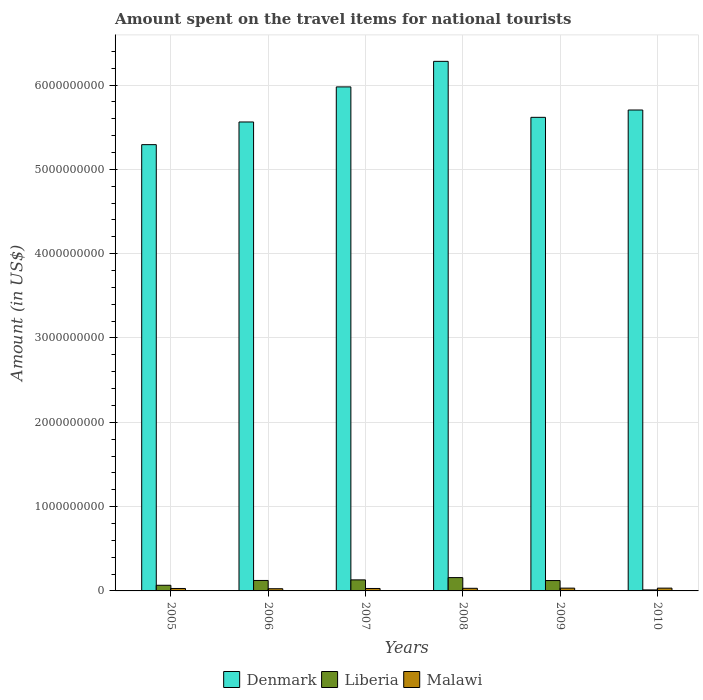How many different coloured bars are there?
Keep it short and to the point. 3. How many groups of bars are there?
Ensure brevity in your answer.  6. Are the number of bars per tick equal to the number of legend labels?
Your response must be concise. Yes. Are the number of bars on each tick of the X-axis equal?
Make the answer very short. Yes. How many bars are there on the 1st tick from the left?
Keep it short and to the point. 3. What is the label of the 3rd group of bars from the left?
Provide a short and direct response. 2007. What is the amount spent on the travel items for national tourists in Denmark in 2008?
Offer a terse response. 6.28e+09. Across all years, what is the maximum amount spent on the travel items for national tourists in Denmark?
Make the answer very short. 6.28e+09. Across all years, what is the minimum amount spent on the travel items for national tourists in Denmark?
Keep it short and to the point. 5.29e+09. In which year was the amount spent on the travel items for national tourists in Malawi minimum?
Offer a terse response. 2006. What is the total amount spent on the travel items for national tourists in Liberia in the graph?
Provide a short and direct response. 6.15e+08. What is the difference between the amount spent on the travel items for national tourists in Malawi in 2005 and that in 2009?
Provide a succinct answer. -4.00e+06. What is the difference between the amount spent on the travel items for national tourists in Malawi in 2010 and the amount spent on the travel items for national tourists in Denmark in 2009?
Keep it short and to the point. -5.58e+09. What is the average amount spent on the travel items for national tourists in Liberia per year?
Your answer should be compact. 1.02e+08. In the year 2007, what is the difference between the amount spent on the travel items for national tourists in Malawi and amount spent on the travel items for national tourists in Denmark?
Your answer should be very brief. -5.95e+09. What is the ratio of the amount spent on the travel items for national tourists in Malawi in 2006 to that in 2009?
Offer a very short reply. 0.79. Is the difference between the amount spent on the travel items for national tourists in Malawi in 2008 and 2009 greater than the difference between the amount spent on the travel items for national tourists in Denmark in 2008 and 2009?
Provide a succinct answer. No. What is the difference between the highest and the second highest amount spent on the travel items for national tourists in Malawi?
Your response must be concise. 0. What is the difference between the highest and the lowest amount spent on the travel items for national tourists in Denmark?
Provide a succinct answer. 9.88e+08. What does the 2nd bar from the left in 2009 represents?
Your response must be concise. Liberia. What does the 2nd bar from the right in 2005 represents?
Ensure brevity in your answer.  Liberia. How many bars are there?
Ensure brevity in your answer.  18. Are all the bars in the graph horizontal?
Your answer should be compact. No. Does the graph contain any zero values?
Ensure brevity in your answer.  No. Where does the legend appear in the graph?
Ensure brevity in your answer.  Bottom center. What is the title of the graph?
Give a very brief answer. Amount spent on the travel items for national tourists. Does "Fiji" appear as one of the legend labels in the graph?
Give a very brief answer. No. What is the Amount (in US$) in Denmark in 2005?
Ensure brevity in your answer.  5.29e+09. What is the Amount (in US$) in Liberia in 2005?
Your answer should be very brief. 6.70e+07. What is the Amount (in US$) in Malawi in 2005?
Provide a short and direct response. 2.90e+07. What is the Amount (in US$) in Denmark in 2006?
Ensure brevity in your answer.  5.56e+09. What is the Amount (in US$) in Liberia in 2006?
Keep it short and to the point. 1.24e+08. What is the Amount (in US$) in Malawi in 2006?
Provide a short and direct response. 2.60e+07. What is the Amount (in US$) of Denmark in 2007?
Your response must be concise. 5.98e+09. What is the Amount (in US$) of Liberia in 2007?
Provide a short and direct response. 1.31e+08. What is the Amount (in US$) of Malawi in 2007?
Give a very brief answer. 2.90e+07. What is the Amount (in US$) of Denmark in 2008?
Keep it short and to the point. 6.28e+09. What is the Amount (in US$) of Liberia in 2008?
Offer a very short reply. 1.58e+08. What is the Amount (in US$) in Malawi in 2008?
Provide a short and direct response. 3.10e+07. What is the Amount (in US$) in Denmark in 2009?
Provide a short and direct response. 5.62e+09. What is the Amount (in US$) in Liberia in 2009?
Ensure brevity in your answer.  1.23e+08. What is the Amount (in US$) in Malawi in 2009?
Ensure brevity in your answer.  3.30e+07. What is the Amount (in US$) of Denmark in 2010?
Give a very brief answer. 5.70e+09. What is the Amount (in US$) of Malawi in 2010?
Make the answer very short. 3.30e+07. Across all years, what is the maximum Amount (in US$) in Denmark?
Provide a short and direct response. 6.28e+09. Across all years, what is the maximum Amount (in US$) in Liberia?
Your response must be concise. 1.58e+08. Across all years, what is the maximum Amount (in US$) of Malawi?
Offer a very short reply. 3.30e+07. Across all years, what is the minimum Amount (in US$) of Denmark?
Ensure brevity in your answer.  5.29e+09. Across all years, what is the minimum Amount (in US$) in Liberia?
Your response must be concise. 1.20e+07. Across all years, what is the minimum Amount (in US$) of Malawi?
Keep it short and to the point. 2.60e+07. What is the total Amount (in US$) in Denmark in the graph?
Your answer should be very brief. 3.44e+1. What is the total Amount (in US$) in Liberia in the graph?
Make the answer very short. 6.15e+08. What is the total Amount (in US$) in Malawi in the graph?
Offer a very short reply. 1.81e+08. What is the difference between the Amount (in US$) in Denmark in 2005 and that in 2006?
Give a very brief answer. -2.69e+08. What is the difference between the Amount (in US$) in Liberia in 2005 and that in 2006?
Offer a very short reply. -5.70e+07. What is the difference between the Amount (in US$) of Malawi in 2005 and that in 2006?
Provide a succinct answer. 3.00e+06. What is the difference between the Amount (in US$) of Denmark in 2005 and that in 2007?
Your answer should be compact. -6.85e+08. What is the difference between the Amount (in US$) in Liberia in 2005 and that in 2007?
Keep it short and to the point. -6.40e+07. What is the difference between the Amount (in US$) of Malawi in 2005 and that in 2007?
Provide a short and direct response. 0. What is the difference between the Amount (in US$) of Denmark in 2005 and that in 2008?
Your response must be concise. -9.88e+08. What is the difference between the Amount (in US$) of Liberia in 2005 and that in 2008?
Ensure brevity in your answer.  -9.10e+07. What is the difference between the Amount (in US$) in Denmark in 2005 and that in 2009?
Ensure brevity in your answer.  -3.24e+08. What is the difference between the Amount (in US$) in Liberia in 2005 and that in 2009?
Offer a terse response. -5.60e+07. What is the difference between the Amount (in US$) in Denmark in 2005 and that in 2010?
Your answer should be compact. -4.11e+08. What is the difference between the Amount (in US$) of Liberia in 2005 and that in 2010?
Give a very brief answer. 5.50e+07. What is the difference between the Amount (in US$) of Malawi in 2005 and that in 2010?
Make the answer very short. -4.00e+06. What is the difference between the Amount (in US$) in Denmark in 2006 and that in 2007?
Provide a succinct answer. -4.16e+08. What is the difference between the Amount (in US$) in Liberia in 2006 and that in 2007?
Ensure brevity in your answer.  -7.00e+06. What is the difference between the Amount (in US$) in Malawi in 2006 and that in 2007?
Ensure brevity in your answer.  -3.00e+06. What is the difference between the Amount (in US$) in Denmark in 2006 and that in 2008?
Provide a short and direct response. -7.19e+08. What is the difference between the Amount (in US$) in Liberia in 2006 and that in 2008?
Ensure brevity in your answer.  -3.40e+07. What is the difference between the Amount (in US$) of Malawi in 2006 and that in 2008?
Offer a terse response. -5.00e+06. What is the difference between the Amount (in US$) of Denmark in 2006 and that in 2009?
Offer a terse response. -5.50e+07. What is the difference between the Amount (in US$) of Liberia in 2006 and that in 2009?
Your answer should be compact. 1.00e+06. What is the difference between the Amount (in US$) of Malawi in 2006 and that in 2009?
Give a very brief answer. -7.00e+06. What is the difference between the Amount (in US$) of Denmark in 2006 and that in 2010?
Your answer should be compact. -1.42e+08. What is the difference between the Amount (in US$) of Liberia in 2006 and that in 2010?
Offer a terse response. 1.12e+08. What is the difference between the Amount (in US$) in Malawi in 2006 and that in 2010?
Make the answer very short. -7.00e+06. What is the difference between the Amount (in US$) in Denmark in 2007 and that in 2008?
Keep it short and to the point. -3.03e+08. What is the difference between the Amount (in US$) of Liberia in 2007 and that in 2008?
Offer a terse response. -2.70e+07. What is the difference between the Amount (in US$) of Denmark in 2007 and that in 2009?
Ensure brevity in your answer.  3.61e+08. What is the difference between the Amount (in US$) in Denmark in 2007 and that in 2010?
Ensure brevity in your answer.  2.74e+08. What is the difference between the Amount (in US$) of Liberia in 2007 and that in 2010?
Give a very brief answer. 1.19e+08. What is the difference between the Amount (in US$) in Malawi in 2007 and that in 2010?
Your answer should be compact. -4.00e+06. What is the difference between the Amount (in US$) in Denmark in 2008 and that in 2009?
Your response must be concise. 6.64e+08. What is the difference between the Amount (in US$) of Liberia in 2008 and that in 2009?
Keep it short and to the point. 3.50e+07. What is the difference between the Amount (in US$) in Denmark in 2008 and that in 2010?
Provide a succinct answer. 5.77e+08. What is the difference between the Amount (in US$) in Liberia in 2008 and that in 2010?
Offer a very short reply. 1.46e+08. What is the difference between the Amount (in US$) of Malawi in 2008 and that in 2010?
Offer a very short reply. -2.00e+06. What is the difference between the Amount (in US$) in Denmark in 2009 and that in 2010?
Provide a short and direct response. -8.70e+07. What is the difference between the Amount (in US$) of Liberia in 2009 and that in 2010?
Give a very brief answer. 1.11e+08. What is the difference between the Amount (in US$) of Malawi in 2009 and that in 2010?
Keep it short and to the point. 0. What is the difference between the Amount (in US$) in Denmark in 2005 and the Amount (in US$) in Liberia in 2006?
Your answer should be compact. 5.17e+09. What is the difference between the Amount (in US$) in Denmark in 2005 and the Amount (in US$) in Malawi in 2006?
Give a very brief answer. 5.27e+09. What is the difference between the Amount (in US$) in Liberia in 2005 and the Amount (in US$) in Malawi in 2006?
Offer a terse response. 4.10e+07. What is the difference between the Amount (in US$) of Denmark in 2005 and the Amount (in US$) of Liberia in 2007?
Your answer should be compact. 5.16e+09. What is the difference between the Amount (in US$) of Denmark in 2005 and the Amount (in US$) of Malawi in 2007?
Your response must be concise. 5.26e+09. What is the difference between the Amount (in US$) in Liberia in 2005 and the Amount (in US$) in Malawi in 2007?
Provide a succinct answer. 3.80e+07. What is the difference between the Amount (in US$) of Denmark in 2005 and the Amount (in US$) of Liberia in 2008?
Your answer should be very brief. 5.14e+09. What is the difference between the Amount (in US$) in Denmark in 2005 and the Amount (in US$) in Malawi in 2008?
Make the answer very short. 5.26e+09. What is the difference between the Amount (in US$) of Liberia in 2005 and the Amount (in US$) of Malawi in 2008?
Keep it short and to the point. 3.60e+07. What is the difference between the Amount (in US$) in Denmark in 2005 and the Amount (in US$) in Liberia in 2009?
Offer a very short reply. 5.17e+09. What is the difference between the Amount (in US$) in Denmark in 2005 and the Amount (in US$) in Malawi in 2009?
Your response must be concise. 5.26e+09. What is the difference between the Amount (in US$) in Liberia in 2005 and the Amount (in US$) in Malawi in 2009?
Give a very brief answer. 3.40e+07. What is the difference between the Amount (in US$) of Denmark in 2005 and the Amount (in US$) of Liberia in 2010?
Your response must be concise. 5.28e+09. What is the difference between the Amount (in US$) in Denmark in 2005 and the Amount (in US$) in Malawi in 2010?
Make the answer very short. 5.26e+09. What is the difference between the Amount (in US$) in Liberia in 2005 and the Amount (in US$) in Malawi in 2010?
Offer a terse response. 3.40e+07. What is the difference between the Amount (in US$) in Denmark in 2006 and the Amount (in US$) in Liberia in 2007?
Offer a terse response. 5.43e+09. What is the difference between the Amount (in US$) of Denmark in 2006 and the Amount (in US$) of Malawi in 2007?
Your response must be concise. 5.53e+09. What is the difference between the Amount (in US$) in Liberia in 2006 and the Amount (in US$) in Malawi in 2007?
Your answer should be compact. 9.50e+07. What is the difference between the Amount (in US$) of Denmark in 2006 and the Amount (in US$) of Liberia in 2008?
Your answer should be compact. 5.40e+09. What is the difference between the Amount (in US$) in Denmark in 2006 and the Amount (in US$) in Malawi in 2008?
Your answer should be compact. 5.53e+09. What is the difference between the Amount (in US$) in Liberia in 2006 and the Amount (in US$) in Malawi in 2008?
Make the answer very short. 9.30e+07. What is the difference between the Amount (in US$) in Denmark in 2006 and the Amount (in US$) in Liberia in 2009?
Provide a succinct answer. 5.44e+09. What is the difference between the Amount (in US$) of Denmark in 2006 and the Amount (in US$) of Malawi in 2009?
Your answer should be very brief. 5.53e+09. What is the difference between the Amount (in US$) of Liberia in 2006 and the Amount (in US$) of Malawi in 2009?
Your answer should be very brief. 9.10e+07. What is the difference between the Amount (in US$) in Denmark in 2006 and the Amount (in US$) in Liberia in 2010?
Your response must be concise. 5.55e+09. What is the difference between the Amount (in US$) in Denmark in 2006 and the Amount (in US$) in Malawi in 2010?
Your response must be concise. 5.53e+09. What is the difference between the Amount (in US$) in Liberia in 2006 and the Amount (in US$) in Malawi in 2010?
Your response must be concise. 9.10e+07. What is the difference between the Amount (in US$) of Denmark in 2007 and the Amount (in US$) of Liberia in 2008?
Your response must be concise. 5.82e+09. What is the difference between the Amount (in US$) in Denmark in 2007 and the Amount (in US$) in Malawi in 2008?
Ensure brevity in your answer.  5.95e+09. What is the difference between the Amount (in US$) of Denmark in 2007 and the Amount (in US$) of Liberia in 2009?
Offer a terse response. 5.86e+09. What is the difference between the Amount (in US$) of Denmark in 2007 and the Amount (in US$) of Malawi in 2009?
Offer a terse response. 5.94e+09. What is the difference between the Amount (in US$) in Liberia in 2007 and the Amount (in US$) in Malawi in 2009?
Keep it short and to the point. 9.80e+07. What is the difference between the Amount (in US$) of Denmark in 2007 and the Amount (in US$) of Liberia in 2010?
Offer a terse response. 5.97e+09. What is the difference between the Amount (in US$) of Denmark in 2007 and the Amount (in US$) of Malawi in 2010?
Offer a very short reply. 5.94e+09. What is the difference between the Amount (in US$) of Liberia in 2007 and the Amount (in US$) of Malawi in 2010?
Keep it short and to the point. 9.80e+07. What is the difference between the Amount (in US$) in Denmark in 2008 and the Amount (in US$) in Liberia in 2009?
Make the answer very short. 6.16e+09. What is the difference between the Amount (in US$) in Denmark in 2008 and the Amount (in US$) in Malawi in 2009?
Ensure brevity in your answer.  6.25e+09. What is the difference between the Amount (in US$) in Liberia in 2008 and the Amount (in US$) in Malawi in 2009?
Provide a succinct answer. 1.25e+08. What is the difference between the Amount (in US$) of Denmark in 2008 and the Amount (in US$) of Liberia in 2010?
Make the answer very short. 6.27e+09. What is the difference between the Amount (in US$) in Denmark in 2008 and the Amount (in US$) in Malawi in 2010?
Give a very brief answer. 6.25e+09. What is the difference between the Amount (in US$) in Liberia in 2008 and the Amount (in US$) in Malawi in 2010?
Make the answer very short. 1.25e+08. What is the difference between the Amount (in US$) of Denmark in 2009 and the Amount (in US$) of Liberia in 2010?
Offer a terse response. 5.60e+09. What is the difference between the Amount (in US$) in Denmark in 2009 and the Amount (in US$) in Malawi in 2010?
Offer a very short reply. 5.58e+09. What is the difference between the Amount (in US$) of Liberia in 2009 and the Amount (in US$) of Malawi in 2010?
Ensure brevity in your answer.  9.00e+07. What is the average Amount (in US$) of Denmark per year?
Offer a very short reply. 5.74e+09. What is the average Amount (in US$) in Liberia per year?
Provide a succinct answer. 1.02e+08. What is the average Amount (in US$) of Malawi per year?
Ensure brevity in your answer.  3.02e+07. In the year 2005, what is the difference between the Amount (in US$) in Denmark and Amount (in US$) in Liberia?
Your answer should be very brief. 5.23e+09. In the year 2005, what is the difference between the Amount (in US$) in Denmark and Amount (in US$) in Malawi?
Make the answer very short. 5.26e+09. In the year 2005, what is the difference between the Amount (in US$) of Liberia and Amount (in US$) of Malawi?
Keep it short and to the point. 3.80e+07. In the year 2006, what is the difference between the Amount (in US$) in Denmark and Amount (in US$) in Liberia?
Offer a very short reply. 5.44e+09. In the year 2006, what is the difference between the Amount (in US$) of Denmark and Amount (in US$) of Malawi?
Give a very brief answer. 5.54e+09. In the year 2006, what is the difference between the Amount (in US$) of Liberia and Amount (in US$) of Malawi?
Your answer should be very brief. 9.80e+07. In the year 2007, what is the difference between the Amount (in US$) of Denmark and Amount (in US$) of Liberia?
Make the answer very short. 5.85e+09. In the year 2007, what is the difference between the Amount (in US$) of Denmark and Amount (in US$) of Malawi?
Provide a short and direct response. 5.95e+09. In the year 2007, what is the difference between the Amount (in US$) of Liberia and Amount (in US$) of Malawi?
Your answer should be compact. 1.02e+08. In the year 2008, what is the difference between the Amount (in US$) in Denmark and Amount (in US$) in Liberia?
Give a very brief answer. 6.12e+09. In the year 2008, what is the difference between the Amount (in US$) in Denmark and Amount (in US$) in Malawi?
Ensure brevity in your answer.  6.25e+09. In the year 2008, what is the difference between the Amount (in US$) of Liberia and Amount (in US$) of Malawi?
Provide a succinct answer. 1.27e+08. In the year 2009, what is the difference between the Amount (in US$) of Denmark and Amount (in US$) of Liberia?
Your answer should be very brief. 5.49e+09. In the year 2009, what is the difference between the Amount (in US$) of Denmark and Amount (in US$) of Malawi?
Keep it short and to the point. 5.58e+09. In the year 2009, what is the difference between the Amount (in US$) in Liberia and Amount (in US$) in Malawi?
Your answer should be very brief. 9.00e+07. In the year 2010, what is the difference between the Amount (in US$) of Denmark and Amount (in US$) of Liberia?
Make the answer very short. 5.69e+09. In the year 2010, what is the difference between the Amount (in US$) in Denmark and Amount (in US$) in Malawi?
Ensure brevity in your answer.  5.67e+09. In the year 2010, what is the difference between the Amount (in US$) of Liberia and Amount (in US$) of Malawi?
Your answer should be compact. -2.10e+07. What is the ratio of the Amount (in US$) in Denmark in 2005 to that in 2006?
Provide a succinct answer. 0.95. What is the ratio of the Amount (in US$) in Liberia in 2005 to that in 2006?
Provide a short and direct response. 0.54. What is the ratio of the Amount (in US$) of Malawi in 2005 to that in 2006?
Give a very brief answer. 1.12. What is the ratio of the Amount (in US$) of Denmark in 2005 to that in 2007?
Your answer should be compact. 0.89. What is the ratio of the Amount (in US$) of Liberia in 2005 to that in 2007?
Provide a short and direct response. 0.51. What is the ratio of the Amount (in US$) in Malawi in 2005 to that in 2007?
Provide a succinct answer. 1. What is the ratio of the Amount (in US$) of Denmark in 2005 to that in 2008?
Provide a short and direct response. 0.84. What is the ratio of the Amount (in US$) of Liberia in 2005 to that in 2008?
Ensure brevity in your answer.  0.42. What is the ratio of the Amount (in US$) in Malawi in 2005 to that in 2008?
Your response must be concise. 0.94. What is the ratio of the Amount (in US$) of Denmark in 2005 to that in 2009?
Give a very brief answer. 0.94. What is the ratio of the Amount (in US$) in Liberia in 2005 to that in 2009?
Make the answer very short. 0.54. What is the ratio of the Amount (in US$) in Malawi in 2005 to that in 2009?
Offer a very short reply. 0.88. What is the ratio of the Amount (in US$) of Denmark in 2005 to that in 2010?
Your answer should be very brief. 0.93. What is the ratio of the Amount (in US$) of Liberia in 2005 to that in 2010?
Offer a very short reply. 5.58. What is the ratio of the Amount (in US$) in Malawi in 2005 to that in 2010?
Make the answer very short. 0.88. What is the ratio of the Amount (in US$) in Denmark in 2006 to that in 2007?
Keep it short and to the point. 0.93. What is the ratio of the Amount (in US$) of Liberia in 2006 to that in 2007?
Ensure brevity in your answer.  0.95. What is the ratio of the Amount (in US$) in Malawi in 2006 to that in 2007?
Keep it short and to the point. 0.9. What is the ratio of the Amount (in US$) of Denmark in 2006 to that in 2008?
Ensure brevity in your answer.  0.89. What is the ratio of the Amount (in US$) of Liberia in 2006 to that in 2008?
Make the answer very short. 0.78. What is the ratio of the Amount (in US$) of Malawi in 2006 to that in 2008?
Give a very brief answer. 0.84. What is the ratio of the Amount (in US$) in Denmark in 2006 to that in 2009?
Ensure brevity in your answer.  0.99. What is the ratio of the Amount (in US$) in Malawi in 2006 to that in 2009?
Provide a succinct answer. 0.79. What is the ratio of the Amount (in US$) in Denmark in 2006 to that in 2010?
Keep it short and to the point. 0.98. What is the ratio of the Amount (in US$) of Liberia in 2006 to that in 2010?
Offer a very short reply. 10.33. What is the ratio of the Amount (in US$) of Malawi in 2006 to that in 2010?
Ensure brevity in your answer.  0.79. What is the ratio of the Amount (in US$) in Denmark in 2007 to that in 2008?
Give a very brief answer. 0.95. What is the ratio of the Amount (in US$) of Liberia in 2007 to that in 2008?
Offer a very short reply. 0.83. What is the ratio of the Amount (in US$) in Malawi in 2007 to that in 2008?
Your answer should be very brief. 0.94. What is the ratio of the Amount (in US$) of Denmark in 2007 to that in 2009?
Provide a succinct answer. 1.06. What is the ratio of the Amount (in US$) in Liberia in 2007 to that in 2009?
Your answer should be compact. 1.06. What is the ratio of the Amount (in US$) in Malawi in 2007 to that in 2009?
Give a very brief answer. 0.88. What is the ratio of the Amount (in US$) of Denmark in 2007 to that in 2010?
Your answer should be very brief. 1.05. What is the ratio of the Amount (in US$) of Liberia in 2007 to that in 2010?
Offer a terse response. 10.92. What is the ratio of the Amount (in US$) in Malawi in 2007 to that in 2010?
Offer a very short reply. 0.88. What is the ratio of the Amount (in US$) of Denmark in 2008 to that in 2009?
Make the answer very short. 1.12. What is the ratio of the Amount (in US$) in Liberia in 2008 to that in 2009?
Offer a terse response. 1.28. What is the ratio of the Amount (in US$) of Malawi in 2008 to that in 2009?
Ensure brevity in your answer.  0.94. What is the ratio of the Amount (in US$) in Denmark in 2008 to that in 2010?
Provide a succinct answer. 1.1. What is the ratio of the Amount (in US$) in Liberia in 2008 to that in 2010?
Your answer should be compact. 13.17. What is the ratio of the Amount (in US$) of Malawi in 2008 to that in 2010?
Offer a very short reply. 0.94. What is the ratio of the Amount (in US$) in Denmark in 2009 to that in 2010?
Provide a succinct answer. 0.98. What is the ratio of the Amount (in US$) of Liberia in 2009 to that in 2010?
Your answer should be compact. 10.25. What is the ratio of the Amount (in US$) of Malawi in 2009 to that in 2010?
Your response must be concise. 1. What is the difference between the highest and the second highest Amount (in US$) in Denmark?
Provide a succinct answer. 3.03e+08. What is the difference between the highest and the second highest Amount (in US$) in Liberia?
Your response must be concise. 2.70e+07. What is the difference between the highest and the lowest Amount (in US$) of Denmark?
Ensure brevity in your answer.  9.88e+08. What is the difference between the highest and the lowest Amount (in US$) of Liberia?
Provide a succinct answer. 1.46e+08. What is the difference between the highest and the lowest Amount (in US$) of Malawi?
Ensure brevity in your answer.  7.00e+06. 